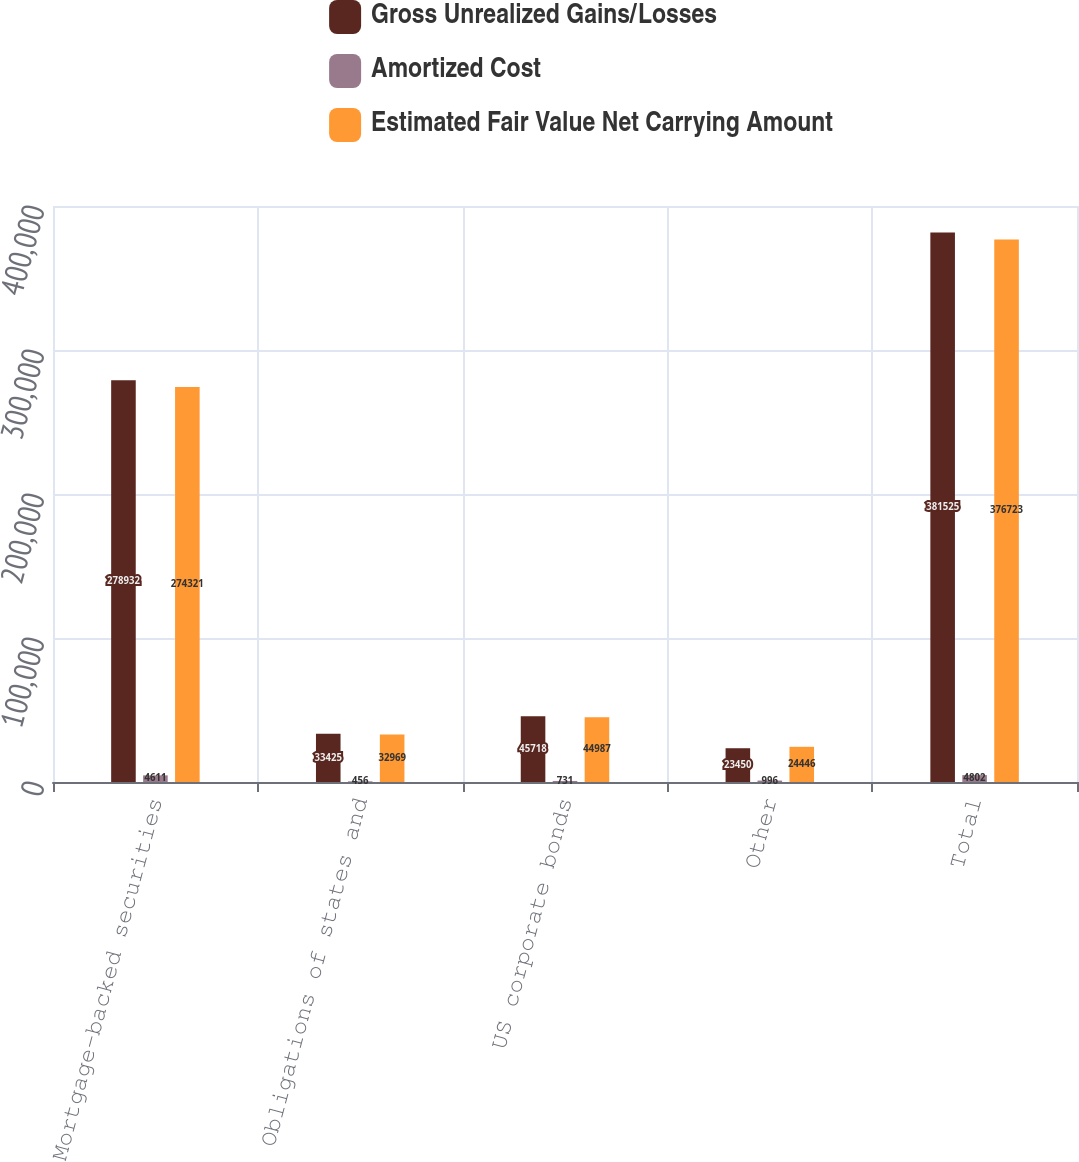Convert chart to OTSL. <chart><loc_0><loc_0><loc_500><loc_500><stacked_bar_chart><ecel><fcel>Mortgage-backed securities<fcel>Obligations of states and<fcel>US corporate bonds<fcel>Other<fcel>Total<nl><fcel>Gross Unrealized Gains/Losses<fcel>278932<fcel>33425<fcel>45718<fcel>23450<fcel>381525<nl><fcel>Amortized Cost<fcel>4611<fcel>456<fcel>731<fcel>996<fcel>4802<nl><fcel>Estimated Fair Value Net Carrying Amount<fcel>274321<fcel>32969<fcel>44987<fcel>24446<fcel>376723<nl></chart> 